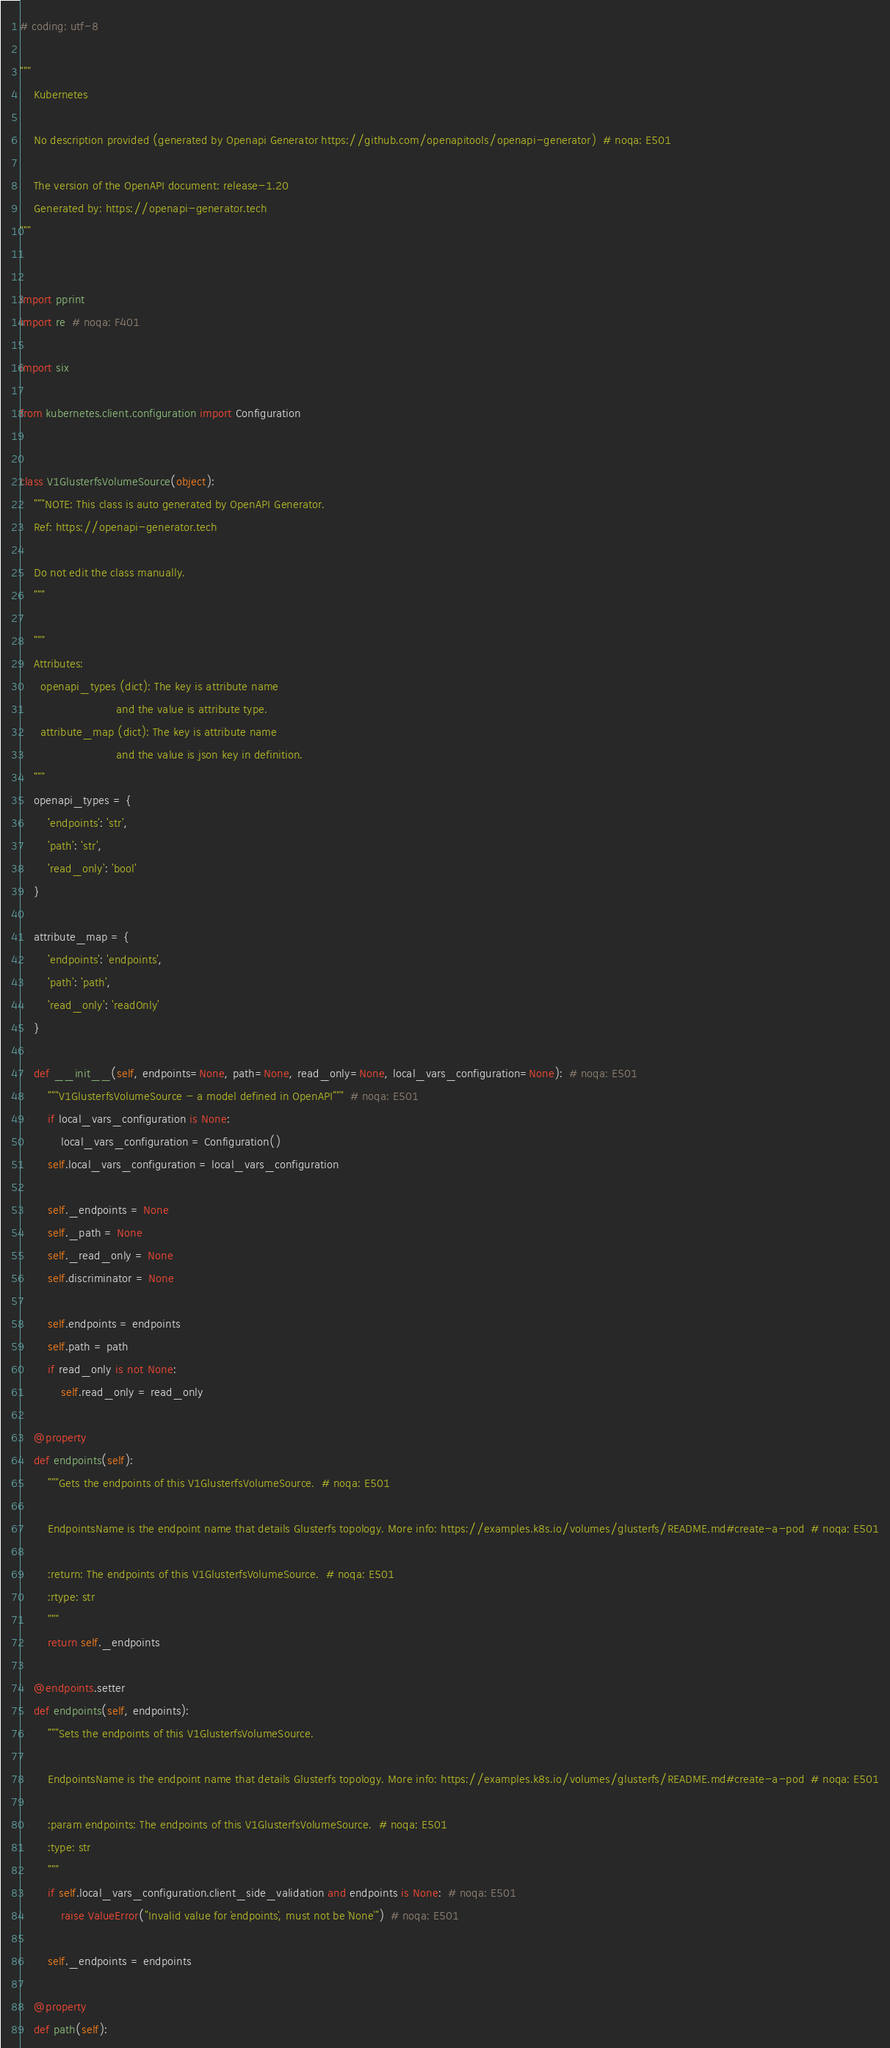Convert code to text. <code><loc_0><loc_0><loc_500><loc_500><_Python_># coding: utf-8

"""
    Kubernetes

    No description provided (generated by Openapi Generator https://github.com/openapitools/openapi-generator)  # noqa: E501

    The version of the OpenAPI document: release-1.20
    Generated by: https://openapi-generator.tech
"""


import pprint
import re  # noqa: F401

import six

from kubernetes.client.configuration import Configuration


class V1GlusterfsVolumeSource(object):
    """NOTE: This class is auto generated by OpenAPI Generator.
    Ref: https://openapi-generator.tech

    Do not edit the class manually.
    """

    """
    Attributes:
      openapi_types (dict): The key is attribute name
                            and the value is attribute type.
      attribute_map (dict): The key is attribute name
                            and the value is json key in definition.
    """
    openapi_types = {
        'endpoints': 'str',
        'path': 'str',
        'read_only': 'bool'
    }

    attribute_map = {
        'endpoints': 'endpoints',
        'path': 'path',
        'read_only': 'readOnly'
    }

    def __init__(self, endpoints=None, path=None, read_only=None, local_vars_configuration=None):  # noqa: E501
        """V1GlusterfsVolumeSource - a model defined in OpenAPI"""  # noqa: E501
        if local_vars_configuration is None:
            local_vars_configuration = Configuration()
        self.local_vars_configuration = local_vars_configuration

        self._endpoints = None
        self._path = None
        self._read_only = None
        self.discriminator = None

        self.endpoints = endpoints
        self.path = path
        if read_only is not None:
            self.read_only = read_only

    @property
    def endpoints(self):
        """Gets the endpoints of this V1GlusterfsVolumeSource.  # noqa: E501

        EndpointsName is the endpoint name that details Glusterfs topology. More info: https://examples.k8s.io/volumes/glusterfs/README.md#create-a-pod  # noqa: E501

        :return: The endpoints of this V1GlusterfsVolumeSource.  # noqa: E501
        :rtype: str
        """
        return self._endpoints

    @endpoints.setter
    def endpoints(self, endpoints):
        """Sets the endpoints of this V1GlusterfsVolumeSource.

        EndpointsName is the endpoint name that details Glusterfs topology. More info: https://examples.k8s.io/volumes/glusterfs/README.md#create-a-pod  # noqa: E501

        :param endpoints: The endpoints of this V1GlusterfsVolumeSource.  # noqa: E501
        :type: str
        """
        if self.local_vars_configuration.client_side_validation and endpoints is None:  # noqa: E501
            raise ValueError("Invalid value for `endpoints`, must not be `None`")  # noqa: E501

        self._endpoints = endpoints

    @property
    def path(self):</code> 